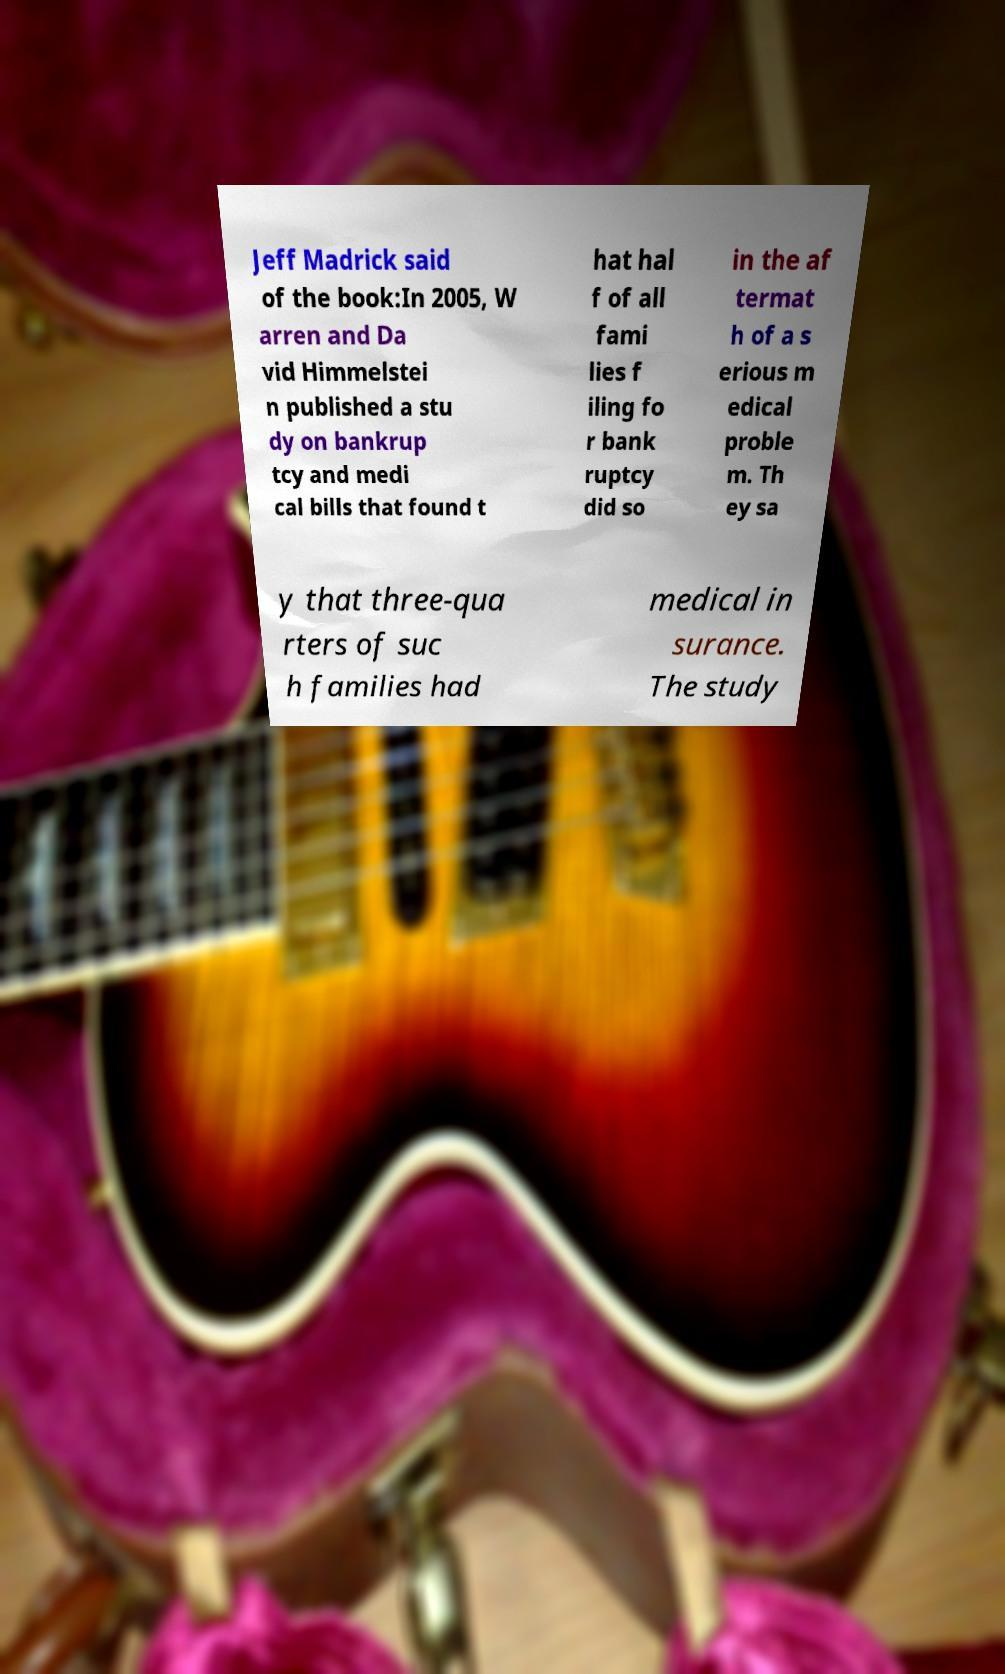Can you read and provide the text displayed in the image?This photo seems to have some interesting text. Can you extract and type it out for me? Jeff Madrick said of the book:In 2005, W arren and Da vid Himmelstei n published a stu dy on bankrup tcy and medi cal bills that found t hat hal f of all fami lies f iling fo r bank ruptcy did so in the af termat h of a s erious m edical proble m. Th ey sa y that three-qua rters of suc h families had medical in surance. The study 